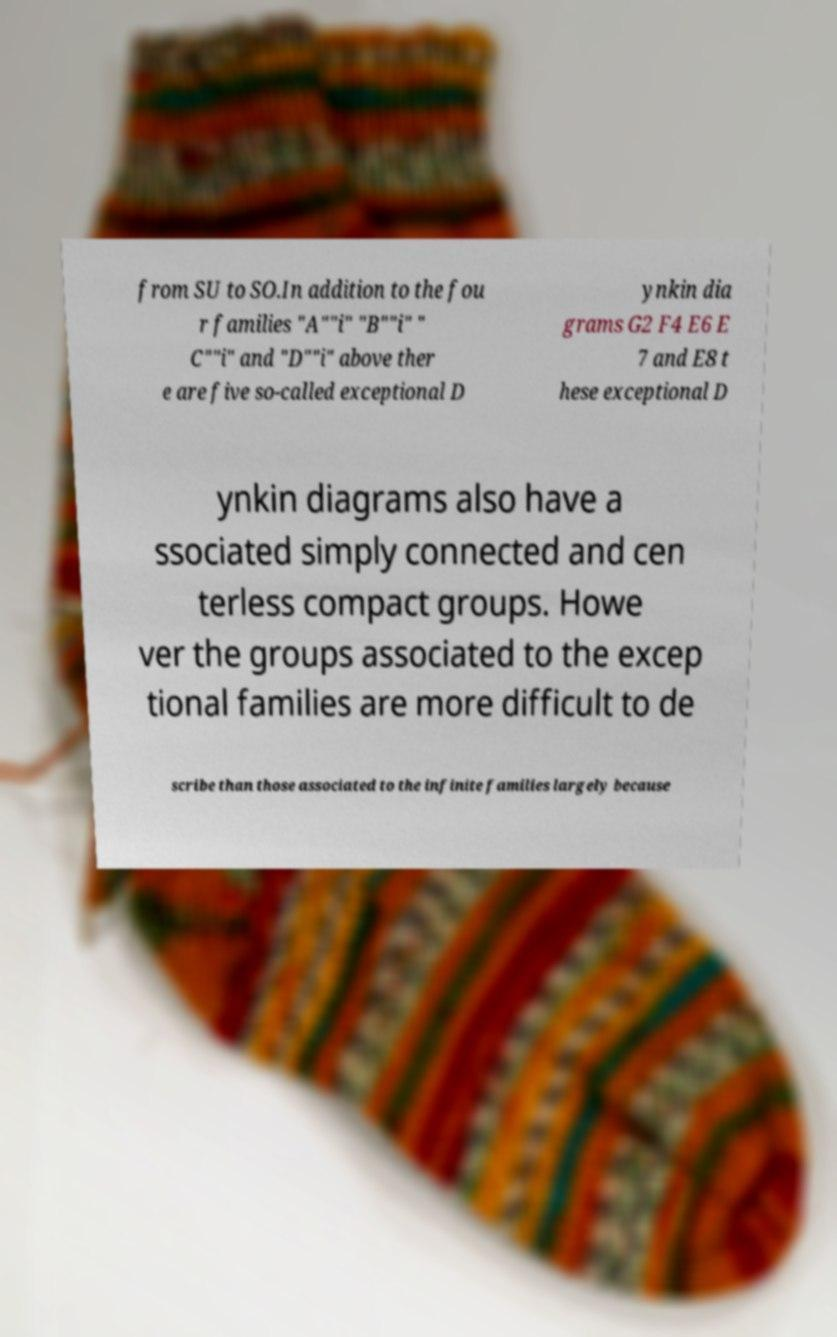What messages or text are displayed in this image? I need them in a readable, typed format. from SU to SO.In addition to the fou r families "A""i" "B""i" " C""i" and "D""i" above ther e are five so-called exceptional D ynkin dia grams G2 F4 E6 E 7 and E8 t hese exceptional D ynkin diagrams also have a ssociated simply connected and cen terless compact groups. Howe ver the groups associated to the excep tional families are more difficult to de scribe than those associated to the infinite families largely because 